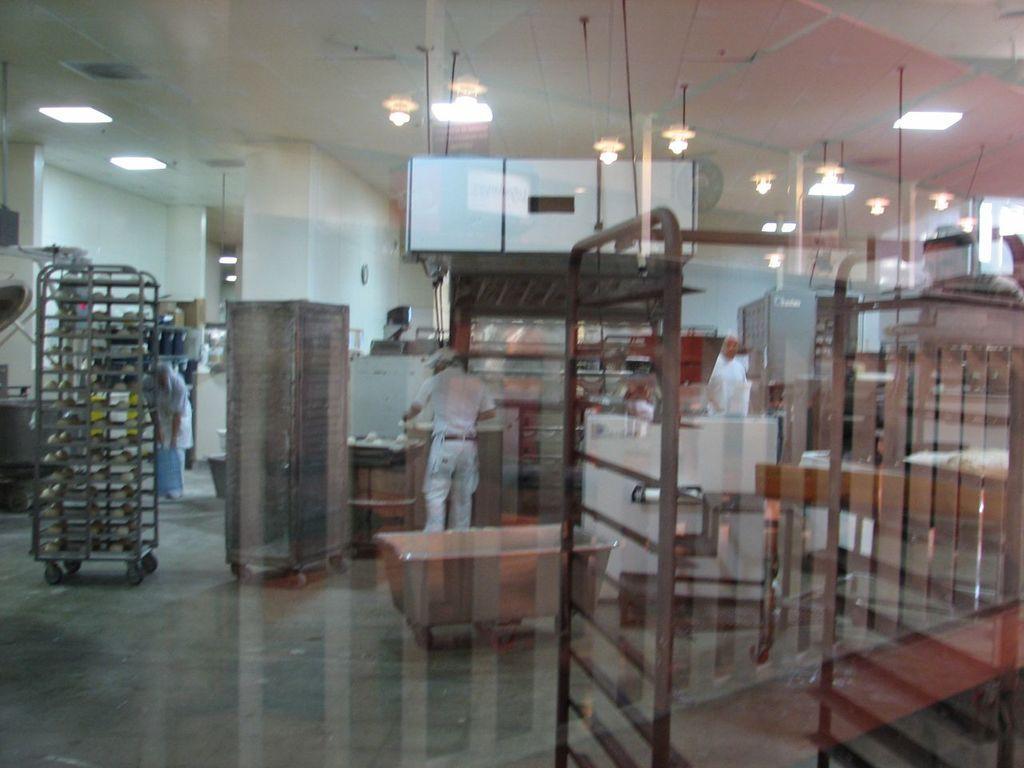Describe this image in one or two sentences. In this image there are people standing on the floor. Left side there is a trolley. Few objects are on the floor. Top of the image few lights are attached to the roof. 